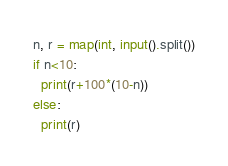Convert code to text. <code><loc_0><loc_0><loc_500><loc_500><_Python_>n, r = map(int, input().split())
if n<10:
  print(r+100*(10-n))
else:
  print(r)</code> 